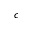Convert formula to latex. <formula><loc_0><loc_0><loc_500><loc_500>c</formula> 